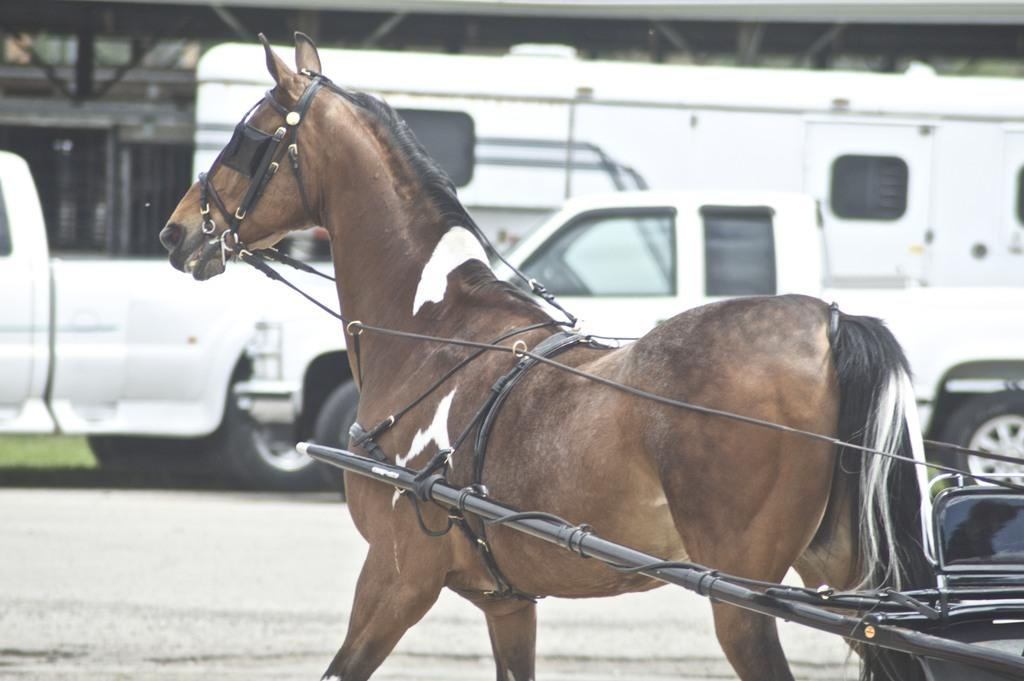What animal is present in the image with a leash? There is a horse with a leash in the image. What is the leash attached to? The leash is attached to a cart. What type of vehicles can be seen on the road in the image? There are cars and a bus on the road in the image. What is the background of the image made of? The background of the image is made of bricks. What type of vegetation is visible in the background of the image? There is grass in the background of the image. What type of crack is visible on the horse's coat in the image? There is no crack visible on the horse's coat in the image. What type of party is being held in the background of the image? There is no party present in the image; it features a horse with a leash, a cart, vehicles on the road, and a brick background with grass. 